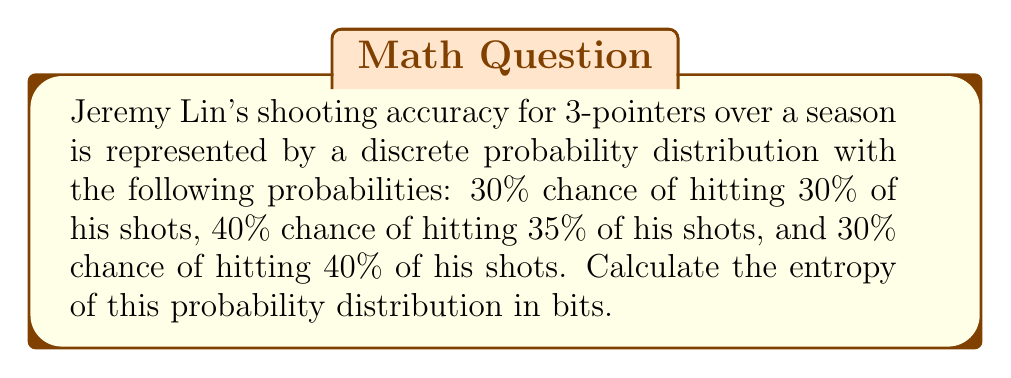Show me your answer to this math problem. Let's approach this step-by-step:

1) The entropy of a discrete probability distribution is given by:

   $$S = -\sum_i p_i \log_2(p_i)$$

   where $p_i$ are the probabilities of each outcome.

2) In this case, we have three probabilities:
   $p_1 = 0.30$ (30% chance of 30% accuracy)
   $p_2 = 0.40$ (40% chance of 35% accuracy)
   $p_3 = 0.30$ (30% chance of 40% accuracy)

3) Let's calculate each term:

   For $p_1$: $-0.30 \log_2(0.30) = -0.30 \times (-1.737) = 0.521$
   For $p_2$: $-0.40 \log_2(0.40) = -0.40 \times (-1.322) = 0.529$
   For $p_3$: $-0.30 \log_2(0.30) = -0.30 \times (-1.737) = 0.521$

4) Now, we sum these terms:

   $$S = 0.521 + 0.529 + 0.521 = 1.571$$

5) Therefore, the entropy of Jeremy Lin's shooting accuracy distribution is approximately 1.571 bits.
Answer: 1.571 bits 